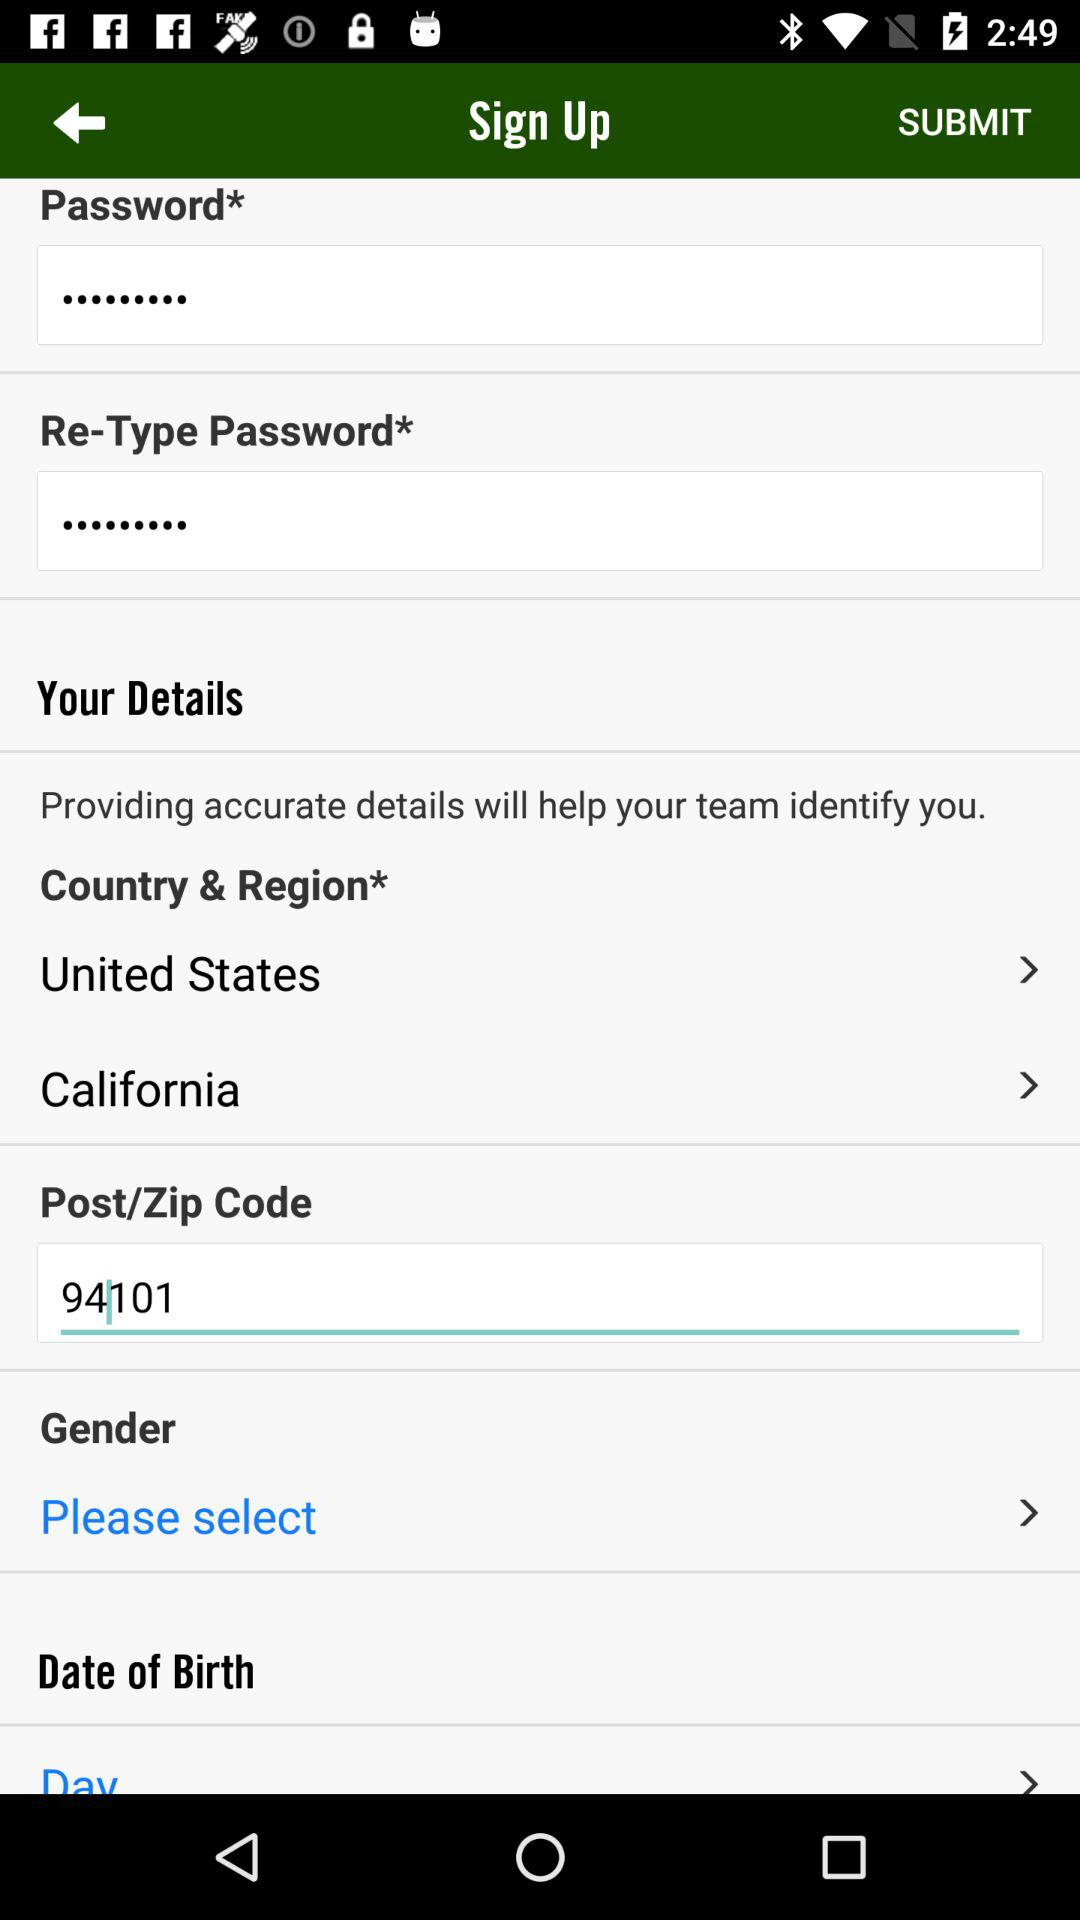What is the zip code? The zip code is 94101. 